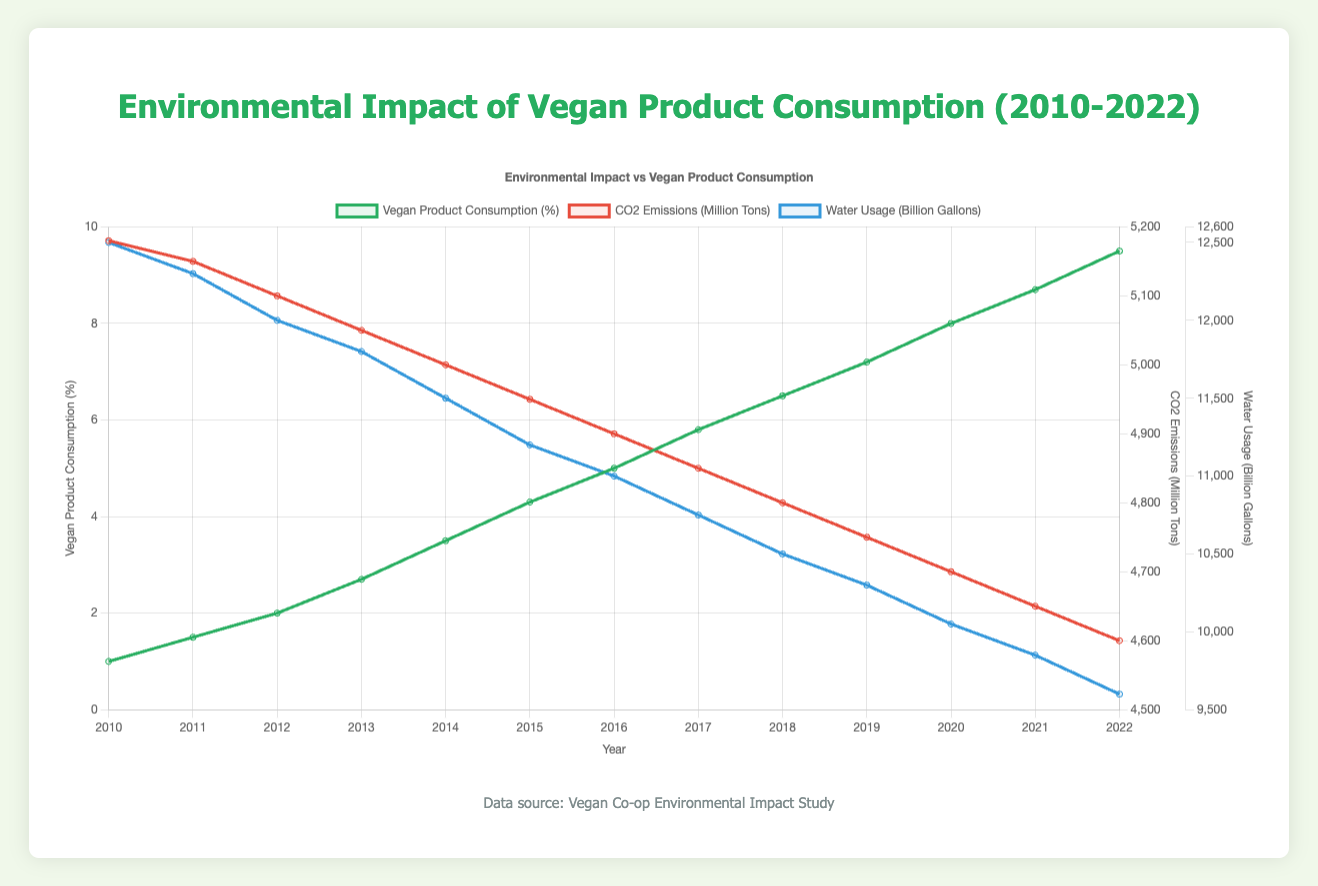What is the average vegan product consumption percentage from 2010 to 2022? Summing the yearly vegan product consumption percentages from 2010 to 2022 is 1.0 + 1.5 + 2.0 + 2.7 + 3.5 + 4.3 + 5.0 + 5.8 + 6.5 + 7.2 + 8.0 + 8.7 + 9.5 = 65.7, and there are 13 years, so the average is 65.7 / 13 ≈ 5.05
Answer: 5.05 How much did CO2 emissions reduce from 2010 to 2022? CO2 emissions in 2010 were 5180 million tons, and in 2022 they were 4600 million tons. The reduction is 5180 - 4600 = 580 million tons.
Answer: 580 What is the trend between vegan product consumption and water usage? As vegan product consumption increases, water usage decreases. This is observed from the decreasing trend in water usage (from 12500 billion gallons in 2010 to 9600 billion gallons in 2022) as the vegan product consumption percentage increases (from 1.0% in 2010 to 9.5% in 2022).
Answer: Decreasing In which year was the lowest water usage recorded? By looking at the chart, the lowest water usage of 9600 billion gallons was recorded in the year 2022.
Answer: 2022 Which year had the largest increase in vegan product consumption percentage? Comparing the yearly increases in vegan product consumption percentage, the largest increase was from 2014 to 2015 (3.5% to 4.3%, which is an increase of 0.8%).
Answer: 2014 to 2015 How do CO2 emissions change as vegan product consumption increases? CO2 emissions decrease as vegan product consumption increases, observed by the downward trend in CO2 emissions from 5180 million tons in 2010 to 4600 million tons in 2022 while vegan product consumption percentages rise from 1.0% to 9.5%.
Answer: Decreasing How much did water usage decrease on average each year from 2010 to 2022? The water usage declined from 12500 billion gallons in 2010 to 9600 billion gallons in 2022, so the total decrease is 12500 - 9600 = 2900 billion gallons. Over 13 years, the average annual decrease is 2900 / 13 ≈ 223.1 billion gallons.
Answer: 223.1 In which year did vegan product consumption percentage first exceed 5%? The vegan product consumption percentage first exceeded 5% in the year 2016 (5.0% in 2016).
Answer: 2016 Compare the CO2 emissions between the years 2012 and 2015. In 2012, CO2 emissions were 5100 million tons, and in 2015, they were 4950 million tons. The reduction from 2012 to 2015 is 5100 - 4950 = 150 million tons.
Answer: 150 